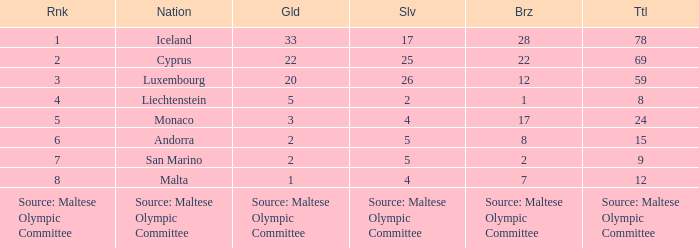What rank is the nation that has a bronze of source: Maltese Olympic Committee? Source: Maltese Olympic Committee. 